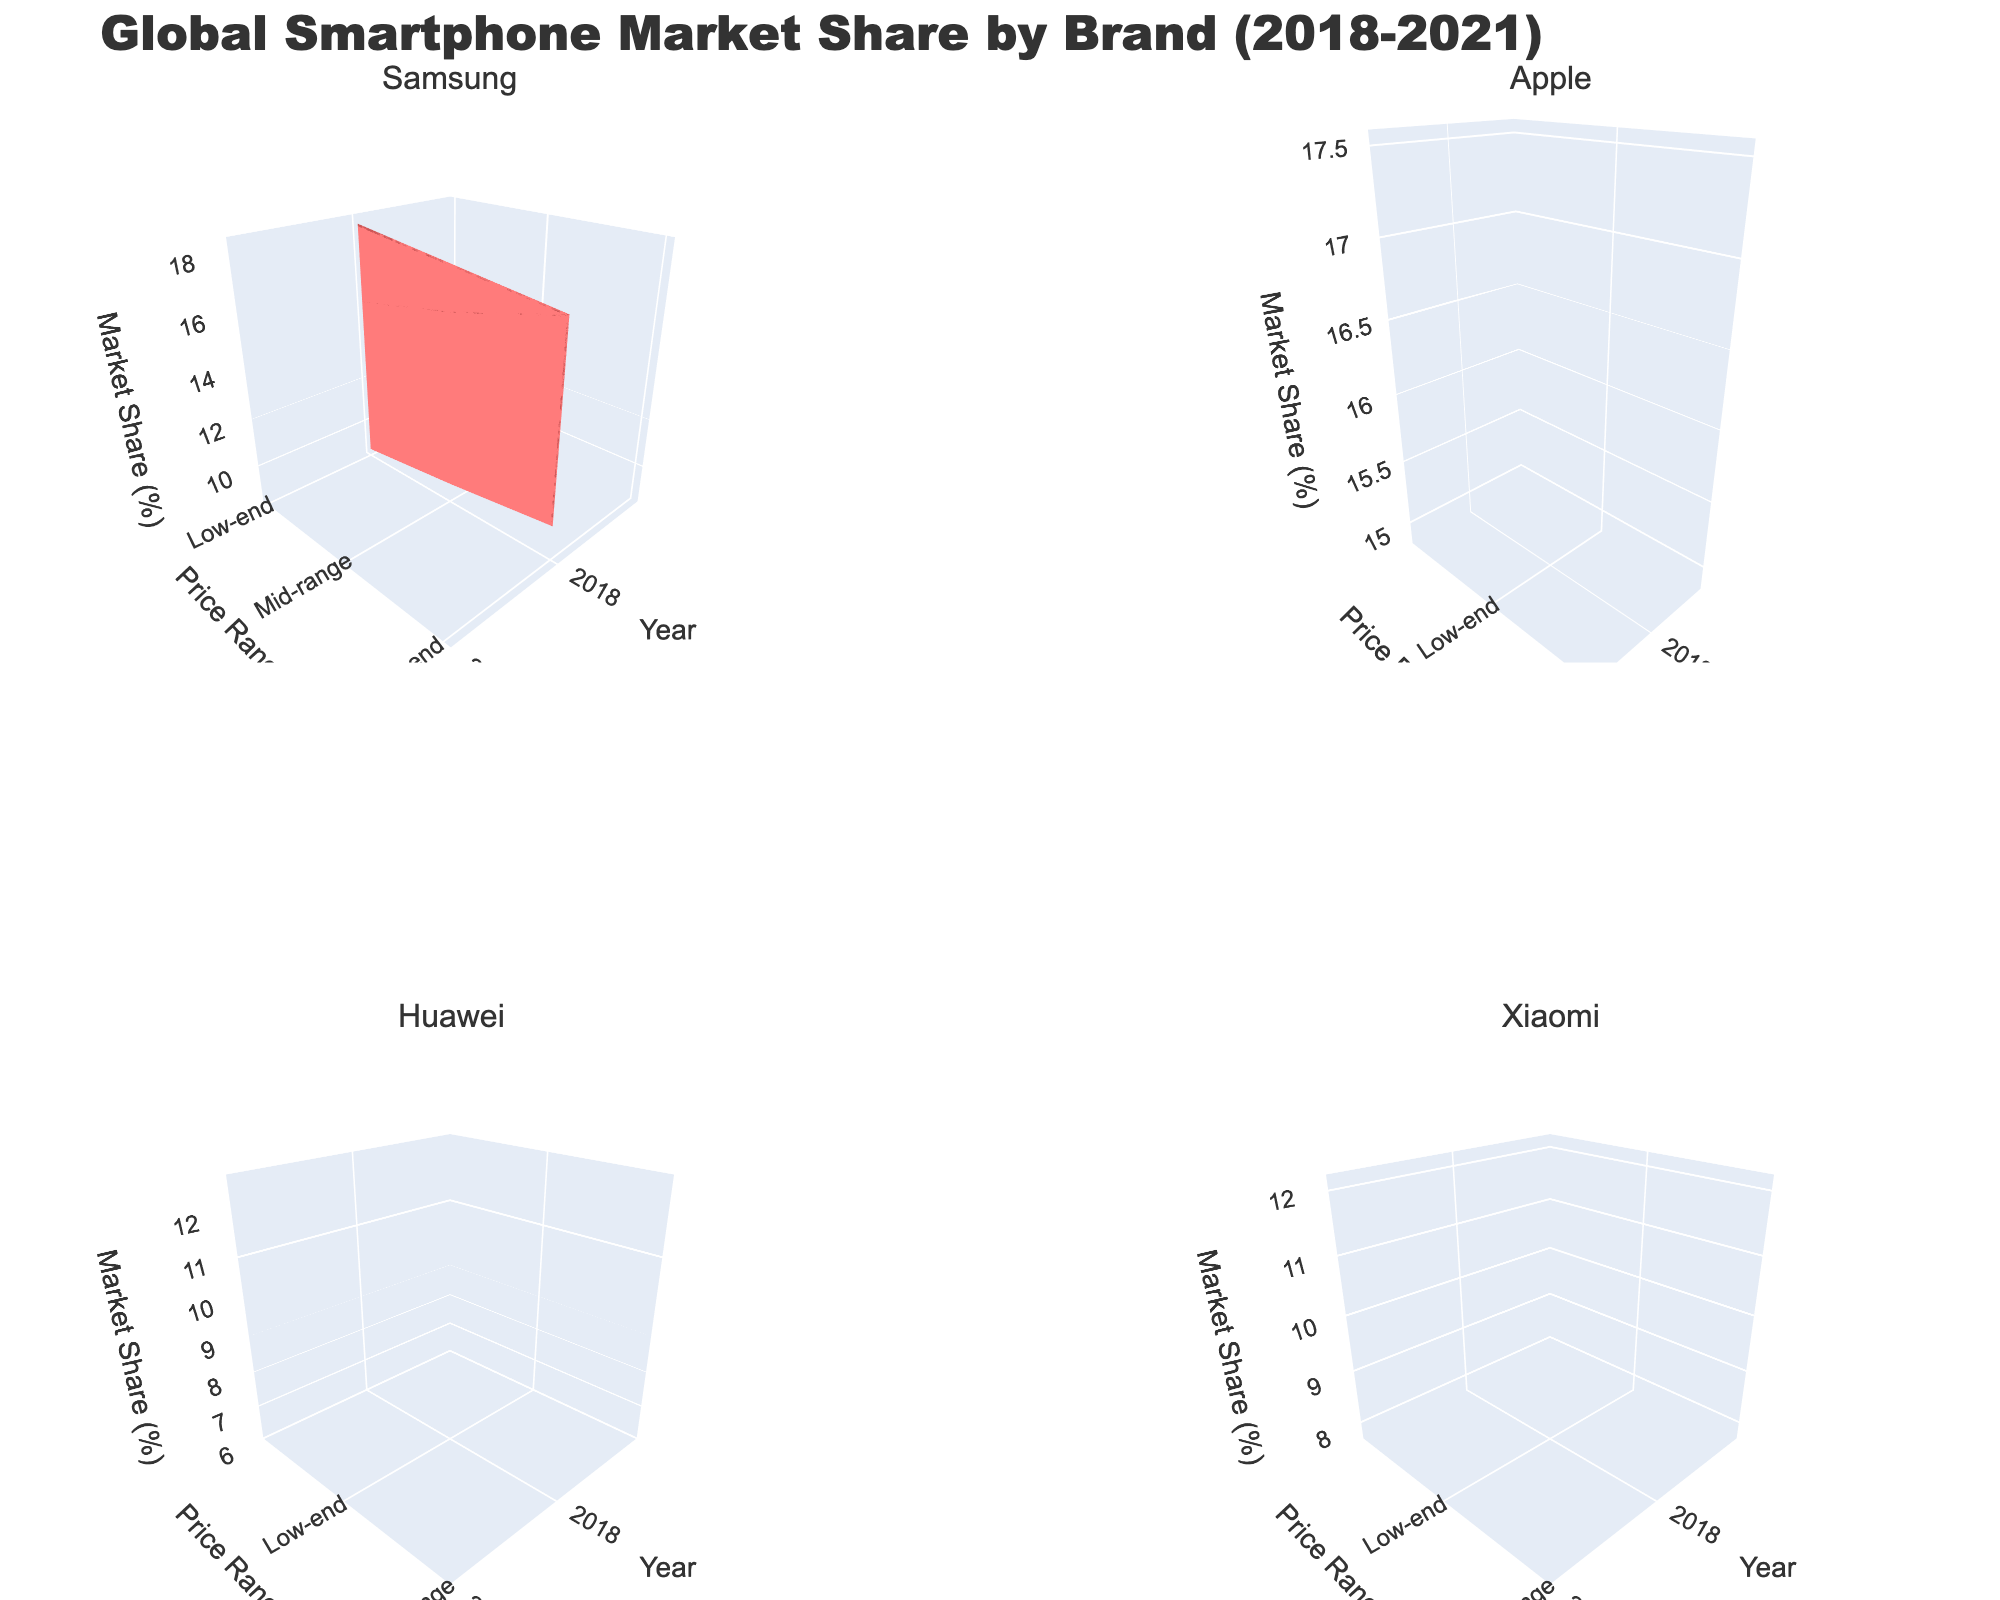What's the title of the figure? The title is displayed at the top of the figure. It usually provides a summary of what the figure is about. In this case, it reads "Global Smartphone Market Share by Brand (2018-2021)."
Answer: Global Smartphone Market Share by Brand (2018-2021) How does Apple's market share in the high-end category change from 2018 to 2021? To answer this question, look at Apple's subplot and observe the z-values (Market Share) for the high-end price range across the years 2018 to 2021.
Answer: It increases from 14.9% to 17.5% Which brand has the highest market share in the mid-range category in 2020? Examine the subplot for each brand and identify the highest market share value in the mid-range category for the year 2020.
Answer: Samsung Compare Samsung's market share in the low-end category in 2019 with Xiaomi's market share in the same category in 2021. Which brand has the higher market share? Look at Samsung's low-end market share in 2019 and Xiaomi's low-end market share in 2021. Compare the two values directly.
Answer: Xiaomi What is the trend in Huawei's market share in the mid-range category from 2018 to 2021? Observe Huawei's subplot and focus on the mid-range category across the years 2018 to 2021. Note the market share values and describe the trend.
Answer: It decreases from 10.2% to 6.2% What is the combined market share for Samsung in the mid-range category for all the years? Add up Samsung's market share values in the mid-range category from 2018 to 2021. The values are 15.3%, 16.1%, 17.2%, and 18.3%.
Answer: 66.9% Which brand shows the most significant increase in market share in the high-end category between 2018 and 2021? Compare the increase in market share in the high-end category from 2018 to 2021 for each brand. Determine which brand has the largest difference.
Answer: Apple 